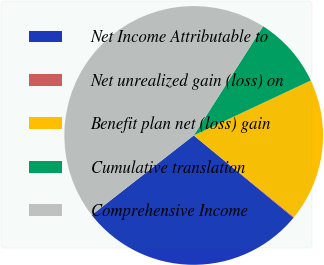Convert chart. <chart><loc_0><loc_0><loc_500><loc_500><pie_chart><fcel>Net Income Attributable to<fcel>Net unrealized gain (loss) on<fcel>Benefit plan net (loss) gain<fcel>Cumulative translation<fcel>Comprehensive Income<nl><fcel>28.48%<fcel>0.12%<fcel>17.84%<fcel>9.01%<fcel>44.55%<nl></chart> 